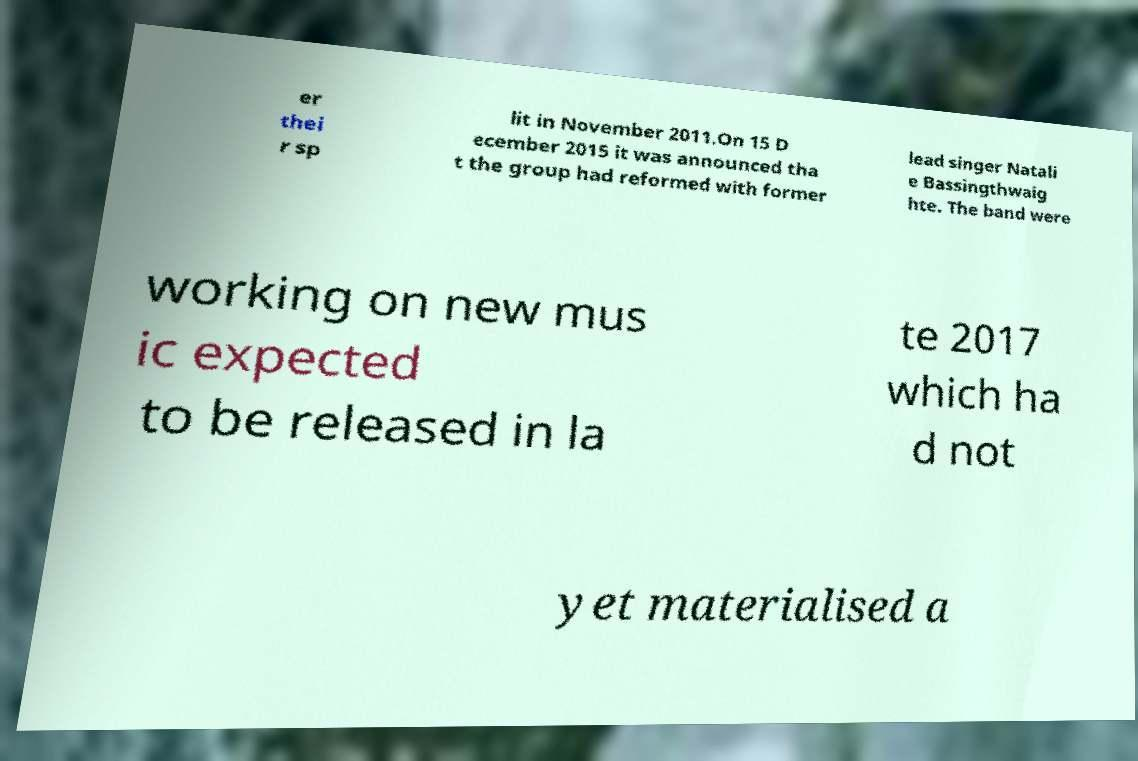I need the written content from this picture converted into text. Can you do that? er thei r sp lit in November 2011.On 15 D ecember 2015 it was announced tha t the group had reformed with former lead singer Natali e Bassingthwaig hte. The band were working on new mus ic expected to be released in la te 2017 which ha d not yet materialised a 